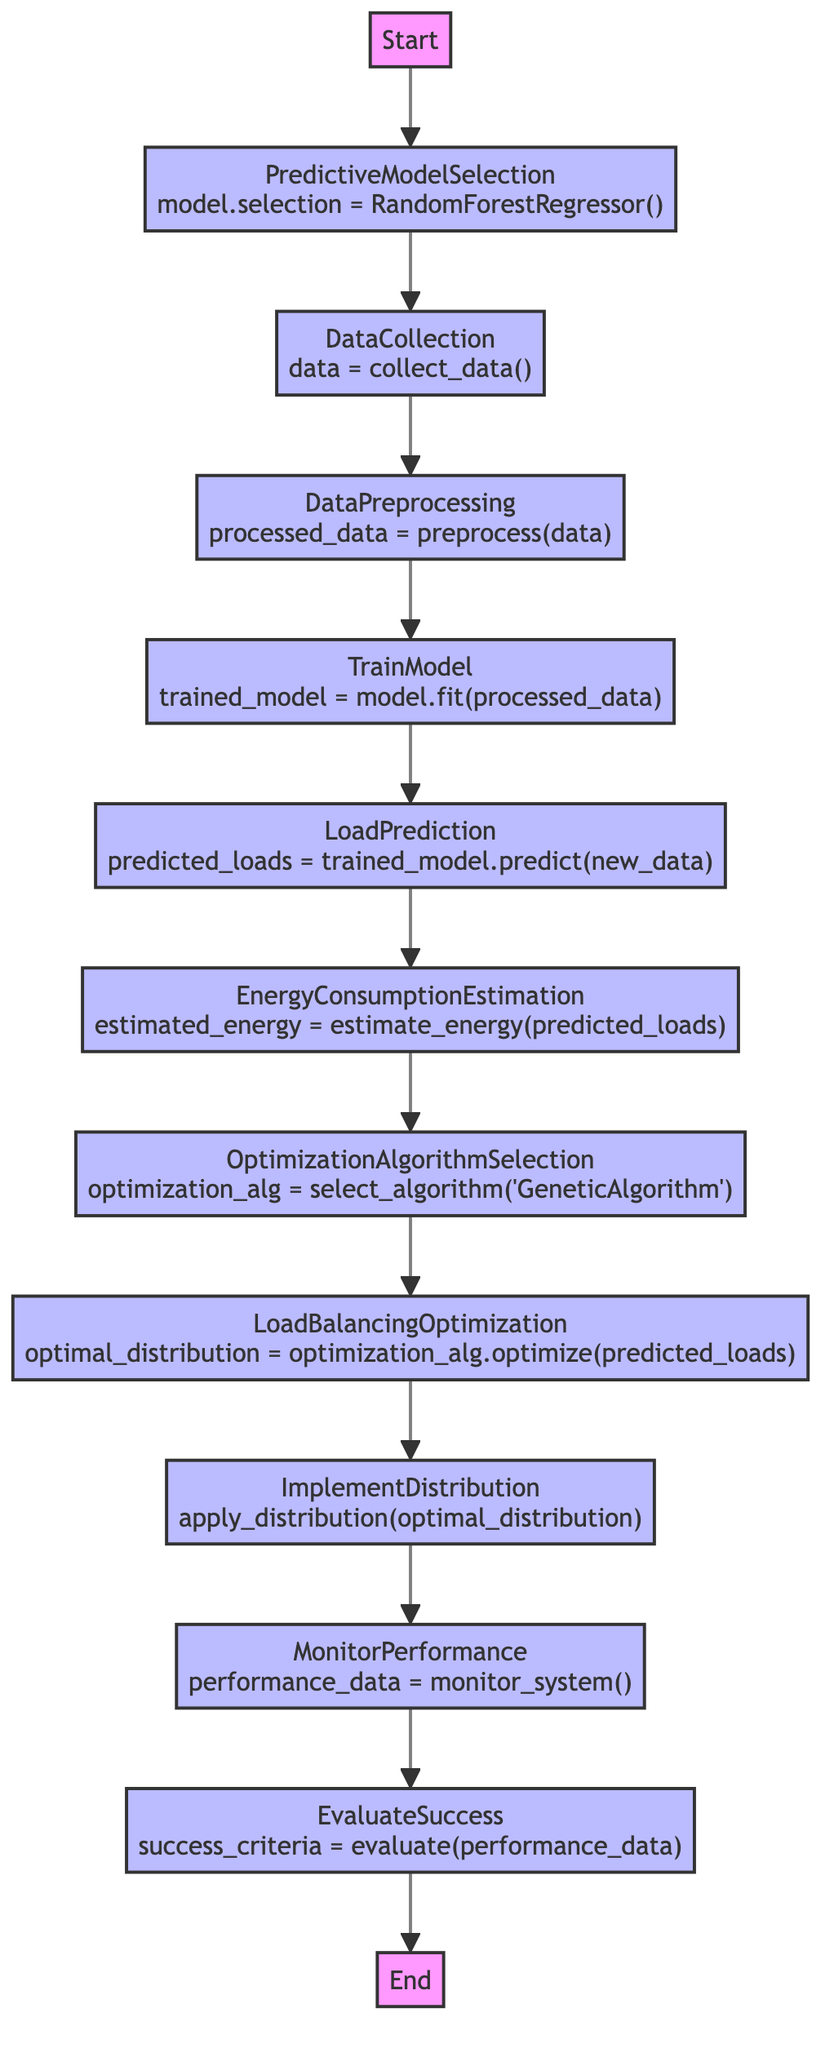What is the first step in the optimization process? The diagram indicates that the first step is labeled "Start," which initiates the optimization process for data center energy consumption.
Answer: Start How many nodes are there in the flowchart? By counting all the labeled nodes from "Start" to "End," there is a total of 13 nodes in the flowchart.
Answer: 13 What machine learning model is selected for load prediction? The operation in the "PredictiveModelSelection" node specifies that the chosen model is "RandomForestRegressor."
Answer: RandomForestRegressor Which mathematical operation is performed in the "LoadPrediction" step? In the "LoadPrediction" node, the operation specified is that the trained model predicts future server loads using the new data.
Answer: predicted_loads = trained_model.predict(new_data) What is the final step after monitoring performance? Following the "MonitorPerformance" node, the next node in the flowchart is "EvaluateSuccess," which evaluates the success of the load balancing optimization.
Answer: EvaluateSuccess What optimization algorithm is selected for load balancing? The "OptimizationAlgorithmSelection" step indicates that the selected optimization algorithm is "GeneticAlgorithm."
Answer: GeneticAlgorithm What is the purpose of the "DataPreprocessing" node? The "DataPreprocessing" step is designed to clean and normalize the collected data to make it suitable for model training.
Answer: Clean and normalize data How does the flowchart ensure energy sustainability in data centers? The flowchart utilizes predictive load balancing and optimization algorithms to minimize energy consumption based on predicted server loads, promoting sustainable computing.
Answer: Minimize energy consumption What is the relation between "LoadBalancingOptimization" and "ImplementDistribution" nodes? "LoadBalancingOptimization" optimizes the load distribution based on predicted loads, and the "ImplementDistribution" step applies this optimized distribution in the data center.
Answer: Optimize then apply distribution 